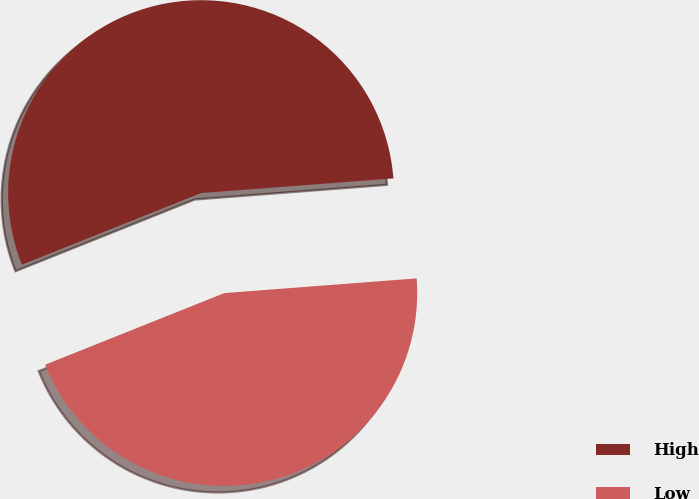Convert chart. <chart><loc_0><loc_0><loc_500><loc_500><pie_chart><fcel>High<fcel>Low<nl><fcel>54.84%<fcel>45.16%<nl></chart> 